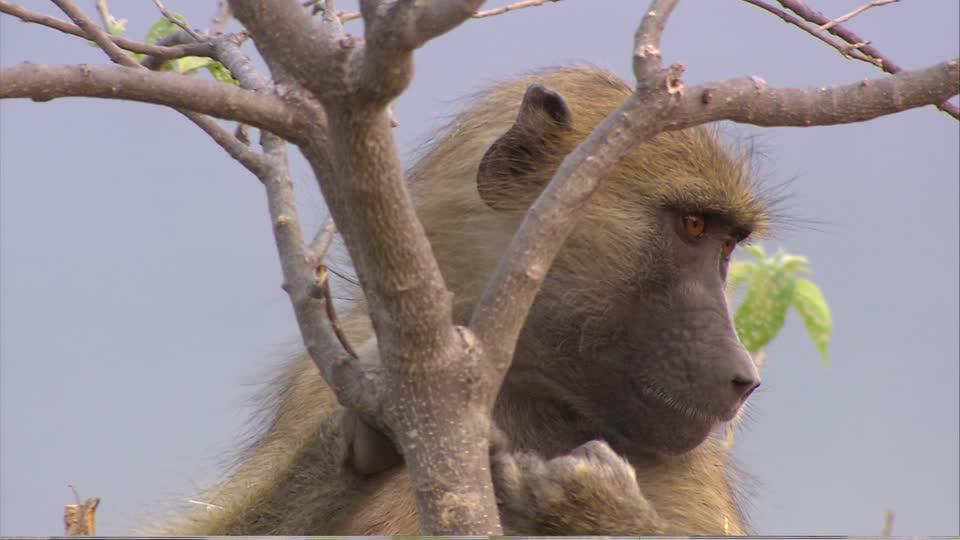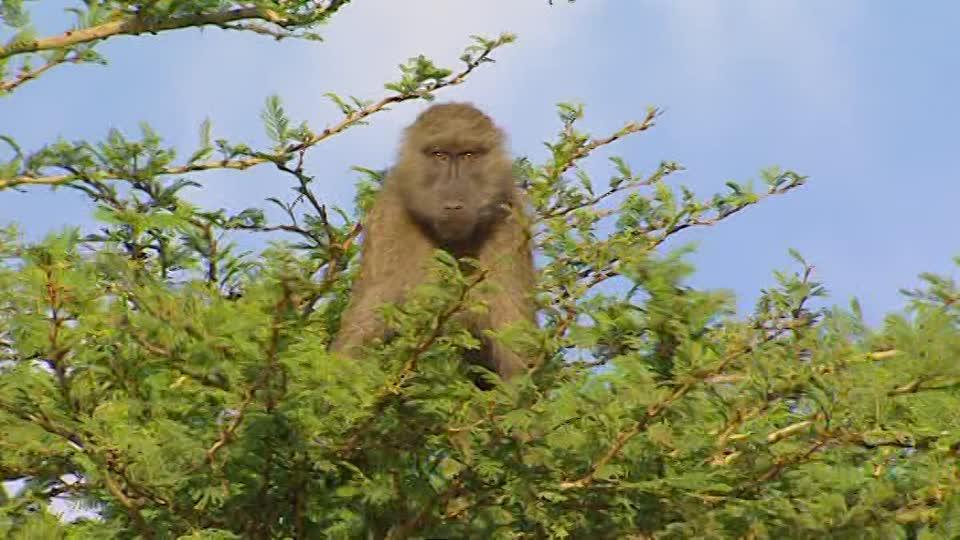The first image is the image on the left, the second image is the image on the right. Evaluate the accuracy of this statement regarding the images: "at least two baboons are climbimg a tree in the image pair". Is it true? Answer yes or no. No. The first image is the image on the left, the second image is the image on the right. Examine the images to the left and right. Is the description "The monkeys are actively climbing trees." accurate? Answer yes or no. No. 